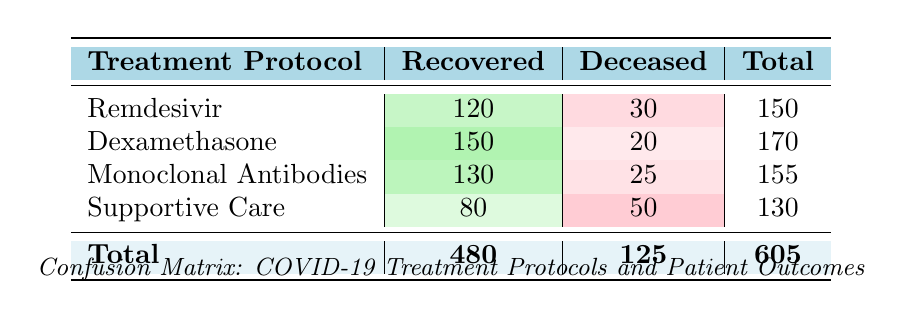What is the total number of patients treated with Dexamethasone? The total number of patients treated with Dexamethasone can be found by adding the Recovered and Deceased patients. From the table, Recovered is 150 and Deceased is 20. Therefore, the total is 150 + 20 = 170.
Answer: 170 How many patients recovered while receiving Remdesivir? The number of patients who recovered while receiving Remdesivir is directly given in the table. It shows that 120 patients recovered.
Answer: 120 Did Monoclonal Antibodies have a higher recovery count than Supportive Care? To determine this, we compare the recovery counts from both protocols. Monoclonal Antibodies shows 130 recoveries and Supportive Care shows 80 recoveries. Since 130 is greater than 80, the statement is true.
Answer: Yes What is the difference in the number of deceased patients between Dexamethasone and Remdesivir protocols? To find the difference, we take the number of deceased patients from each protocol. Dexamethasone has 20 deceased while Remdesivir has 30 deceased. The difference is 30 - 20 = 10.
Answer: 10 What is the average number of recovered patients across all treatment protocols? To calculate the average number of recovered patients, sum the recovered counts (120 + 150 + 130 + 80 = 480) and divide by the number of protocols (4). Thus, 480 / 4 = 120.
Answer: 120 Which treatment protocol has the highest recovery rate? To find the highest recovery rate, we need to determine the recovery rate for each protocol by comparing the recovered counts. Dexamethasone has the highest recovery count of 150, which is more than any of the others.
Answer: Dexamethasone How many total patients were observed in this study? The total number of patients can be obtained from the summary provided at the bottom of the table, which states the total is 605.
Answer: 605 Is the number of recovered patients higher than the number of deceased patients? To answer this question, we look at the total recovered and total deceased counts. The total recovered is 480 and the total deceased is 125. Since 480 is greater than 125, the statement is true.
Answer: Yes 